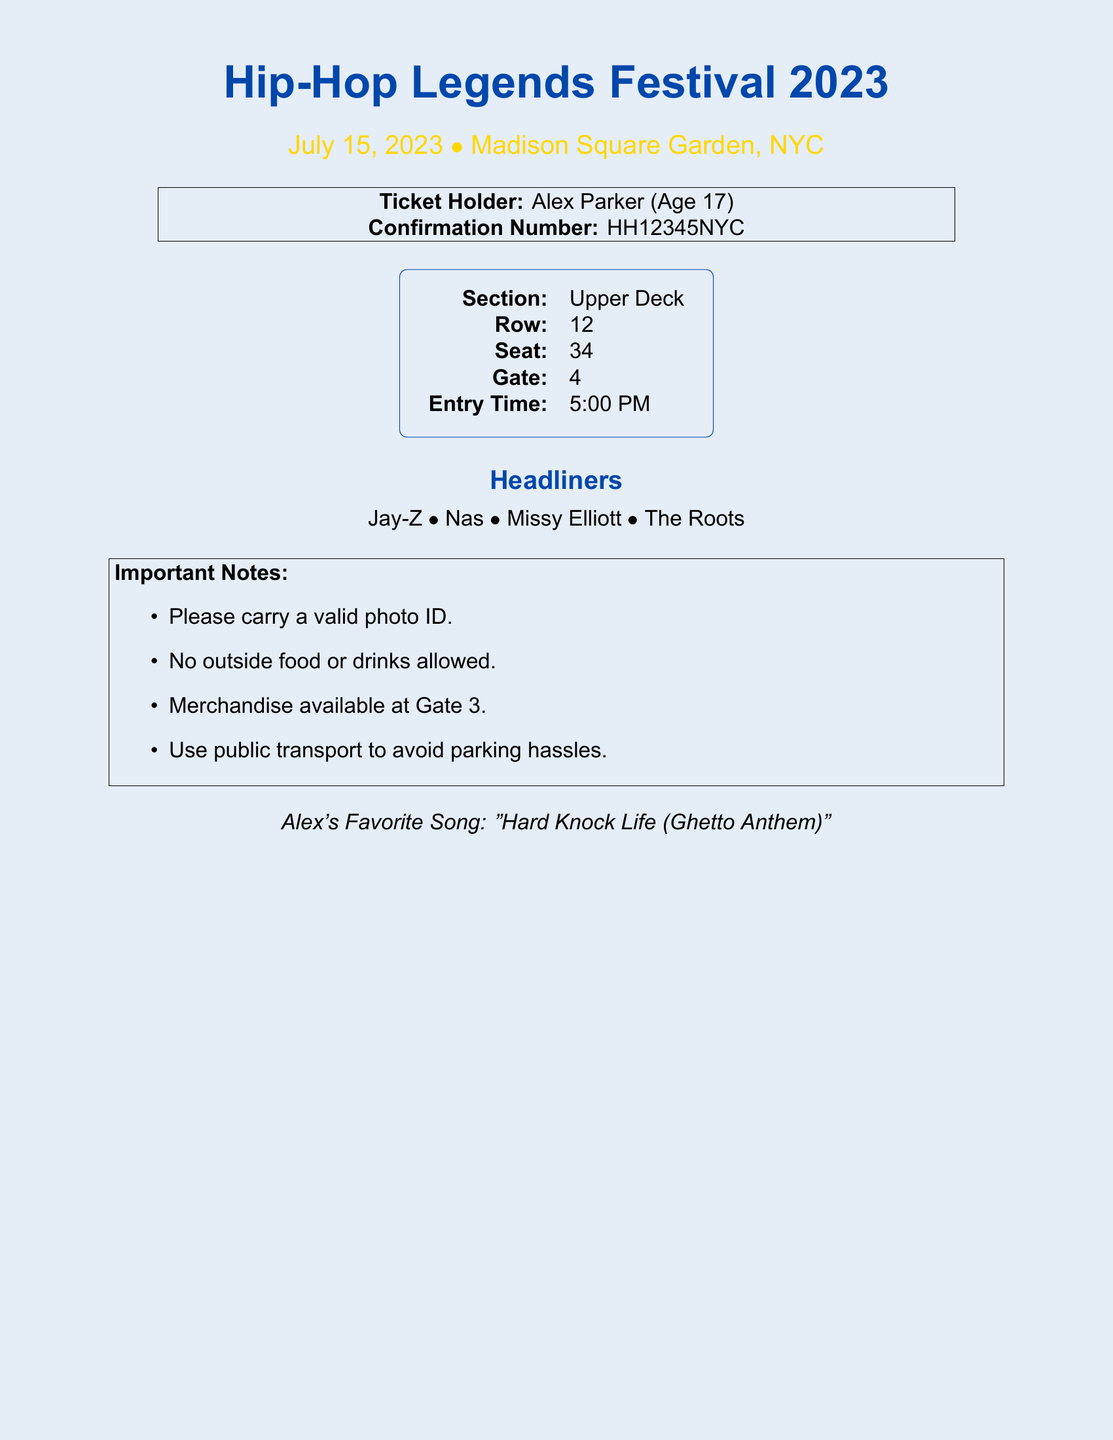What is the name of the festival? The name of the festival is prominently displayed at the top of the document.
Answer: Hip-Hop Legends Festival 2023 What is the date of the festival? The date is mentioned right below the festival name.
Answer: July 15, 2023 Who is the ticket holder? The ticket holder's name is listed in the ticket holder section of the document.
Answer: Alex Parker What is the confirmation number? The confirmation number is explicitly stated in the document.
Answer: HH12345NYC What section is the seat located in? The seating section is found in the seating details section of the document.
Answer: Upper Deck What row is the seat in? The row number is provided alongside the section and seat number.
Answer: 12 What is the entry time? The entry time is included in the seating details of the document.
Answer: 5:00 PM Which gate should the ticket holder use? The gate information is mentioned in the seating details.
Answer: 4 What is one important note mentioned in the document? Important notes are listed in a dedicated section; one item can be chosen for the answer.
Answer: Please carry a valid photo ID Who are some of the headliners? The headliners are listed clearly in the document right before the notes.
Answer: Jay-Z, Nas, Missy Elliott, The Roots 